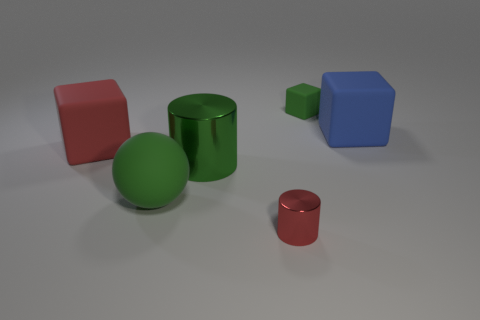How is the lighting arranged in the scene to affect the appearance of these objects? The lighting in the scene appears to be coming from above, casting subtle shadows directly beneath the objects. This overhead lighting accentuates the shapes, and the matte or reflective properties of the object surfaces help highlight their material characteristics, enhancing the three-dimensionality of the composition. 